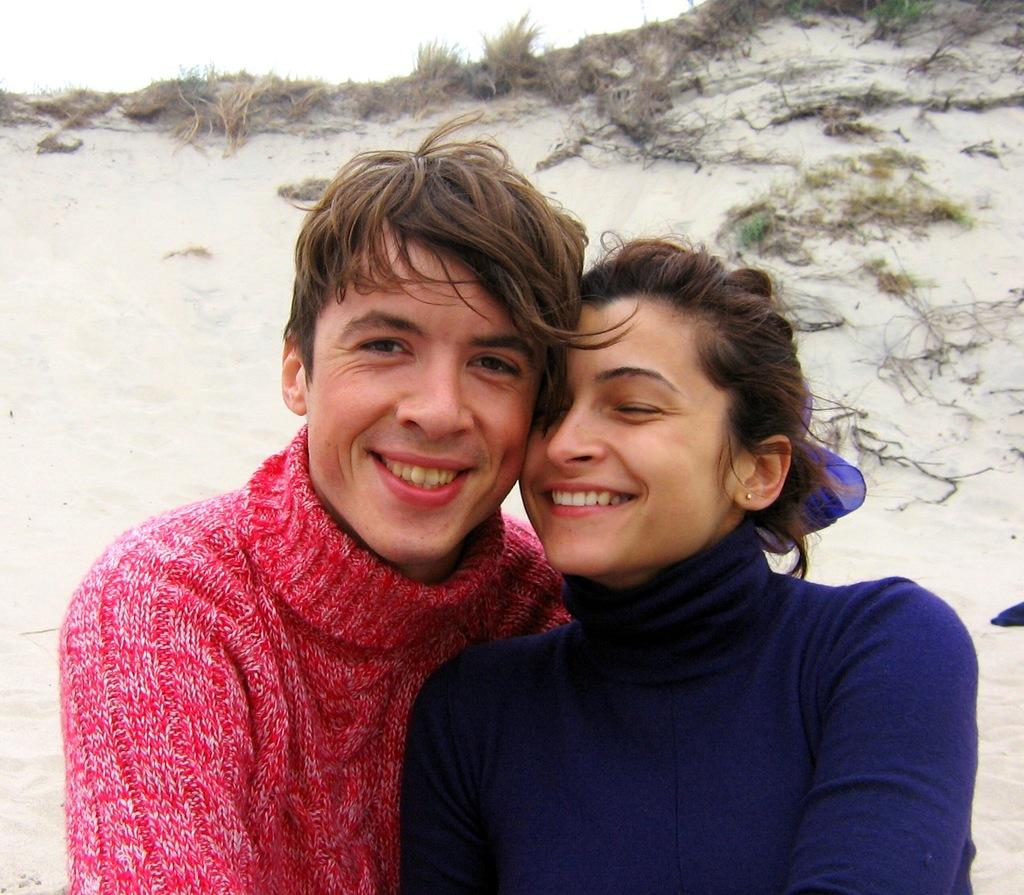How many people are in the image? There are two persons in the image. What is the facial expression of the persons in the image? The persons are smiling. What type of natural environment is visible in the background? There are plants and grass visible in the background. What is visible in the sky in the image? The sky is visible in the background. What type of cloth is being used to cover the marble in the image? There is no cloth or marble present in the image. What is the process of creating the pattern on the cloth in the image? There is no cloth or pattern visible in the image. 